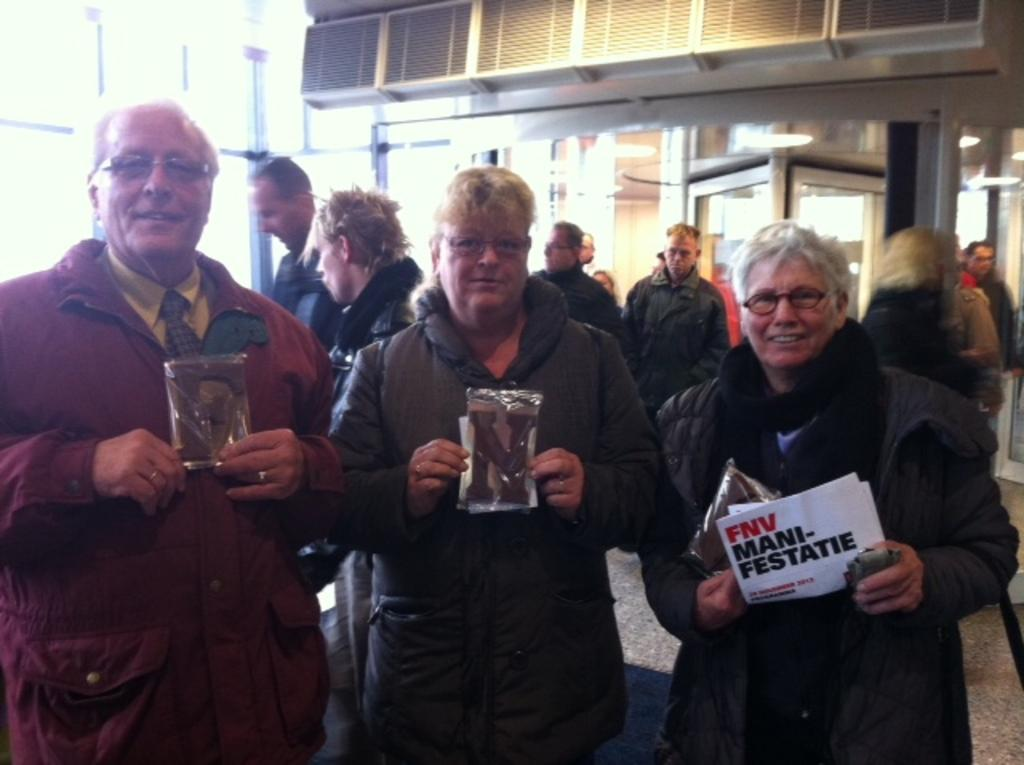How many people are standing in the image? There are three persons standing in the image. What are the three persons holding in their hands? The three persons are holding something in their hands, but the specific objects are not mentioned in the facts. What accessory are the three persons wearing? The three persons are wearing glasses. Can you describe the background of the image? There are many people in the background, and there are glass walls in the background. What type of education is being taught in the class depicted in the image? There is no class or educational setting depicted in the image; it features three persons standing and holding something in their hands. Can you tell me the gender of the woman in the image? There is no woman mentioned in the facts, nor is there any indication of gender for the three persons standing. 